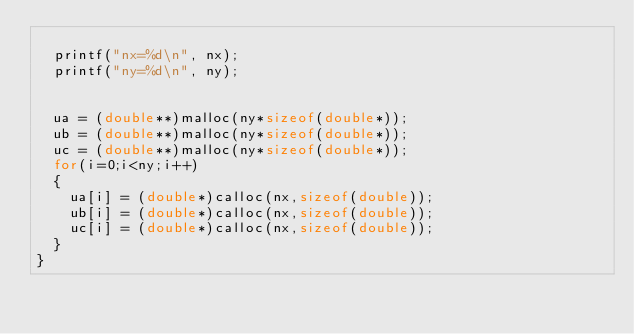Convert code to text. <code><loc_0><loc_0><loc_500><loc_500><_C_>
	printf("nx=%d\n", nx);
	printf("ny=%d\n", ny);

	
	ua = (double**)malloc(ny*sizeof(double*));
	ub = (double**)malloc(ny*sizeof(double*));
	uc = (double**)malloc(ny*sizeof(double*));
	for(i=0;i<ny;i++)
	{
		ua[i] = (double*)calloc(nx,sizeof(double));
		ub[i] = (double*)calloc(nx,sizeof(double));
		uc[i] = (double*)calloc(nx,sizeof(double));
	}
}
</code> 